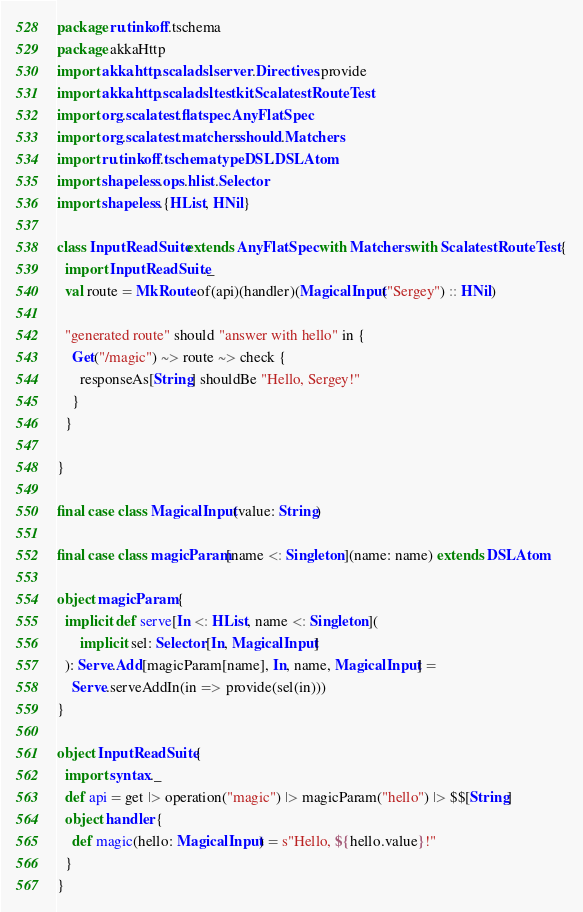Convert code to text. <code><loc_0><loc_0><loc_500><loc_500><_Scala_>package ru.tinkoff.tschema
package akkaHttp
import akka.http.scaladsl.server.Directives.provide
import akka.http.scaladsl.testkit.ScalatestRouteTest
import org.scalatest.flatspec.AnyFlatSpec
import org.scalatest.matchers.should.Matchers
import ru.tinkoff.tschema.typeDSL.DSLAtom
import shapeless.ops.hlist.Selector
import shapeless.{HList, HNil}

class InputReadSuite extends AnyFlatSpec with Matchers with ScalatestRouteTest {
  import InputReadSuite._
  val route = MkRoute.of(api)(handler)(MagicalInput("Sergey") :: HNil)

  "generated route" should "answer with hello" in {
    Get("/magic") ~> route ~> check {
      responseAs[String] shouldBe "Hello, Sergey!"
    }
  }

}

final case class MagicalInput(value: String)

final case class magicParam[name <: Singleton](name: name) extends DSLAtom

object magicParam {
  implicit def serve[In <: HList, name <: Singleton](
      implicit sel: Selector[In, MagicalInput]
  ): Serve.Add[magicParam[name], In, name, MagicalInput] =
    Serve.serveAddIn(in => provide(sel(in)))
}

object InputReadSuite {
  import syntax._
  def api = get |> operation("magic") |> magicParam("hello") |> $$[String]
  object handler {
    def magic(hello: MagicalInput) = s"Hello, ${hello.value}!"
  }
}
</code> 